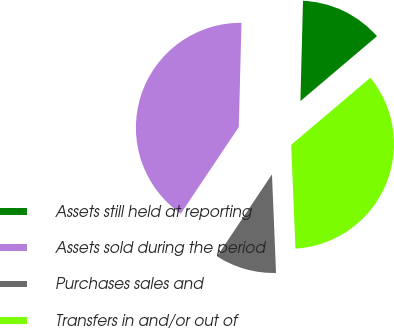<chart> <loc_0><loc_0><loc_500><loc_500><pie_chart><fcel>Assets still held at reporting<fcel>Assets sold during the period<fcel>Purchases sales and<fcel>Transfers in and/or out of<nl><fcel>13.4%<fcel>41.02%<fcel>10.05%<fcel>35.52%<nl></chart> 